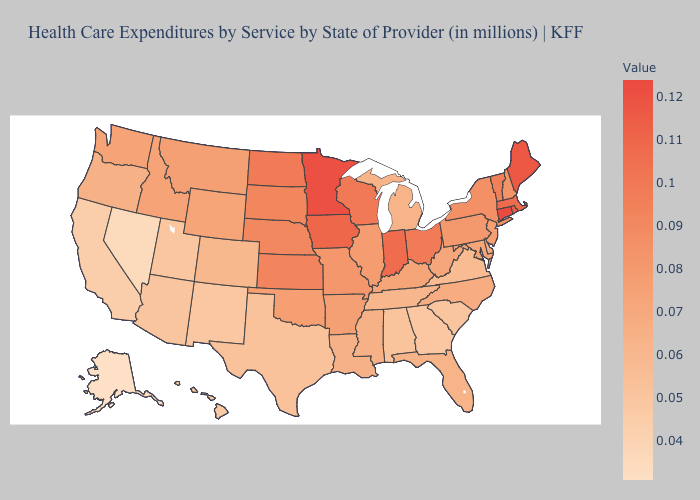Does Minnesota have a higher value than North Carolina?
Keep it brief. Yes. Among the states that border New Jersey , which have the lowest value?
Answer briefly. Delaware. Which states hav the highest value in the MidWest?
Be succinct. Minnesota. Which states have the highest value in the USA?
Write a very short answer. Connecticut. Which states hav the highest value in the MidWest?
Give a very brief answer. Minnesota. Is the legend a continuous bar?
Keep it brief. Yes. Does Wisconsin have the lowest value in the USA?
Answer briefly. No. Does Vermont have the highest value in the USA?
Keep it brief. No. 